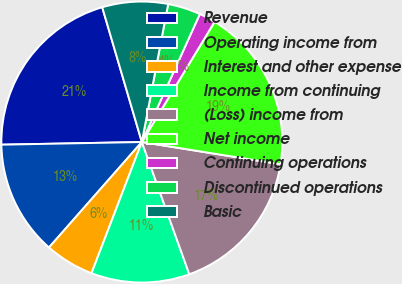Convert chart. <chart><loc_0><loc_0><loc_500><loc_500><pie_chart><fcel>Revenue<fcel>Operating income from<fcel>Interest and other expense<fcel>Income from continuing<fcel>(Loss) income from<fcel>Net income<fcel>Continuing operations<fcel>Discontinued operations<fcel>Basic<nl><fcel>20.75%<fcel>13.21%<fcel>5.66%<fcel>11.32%<fcel>16.98%<fcel>18.87%<fcel>1.89%<fcel>3.77%<fcel>7.55%<nl></chart> 